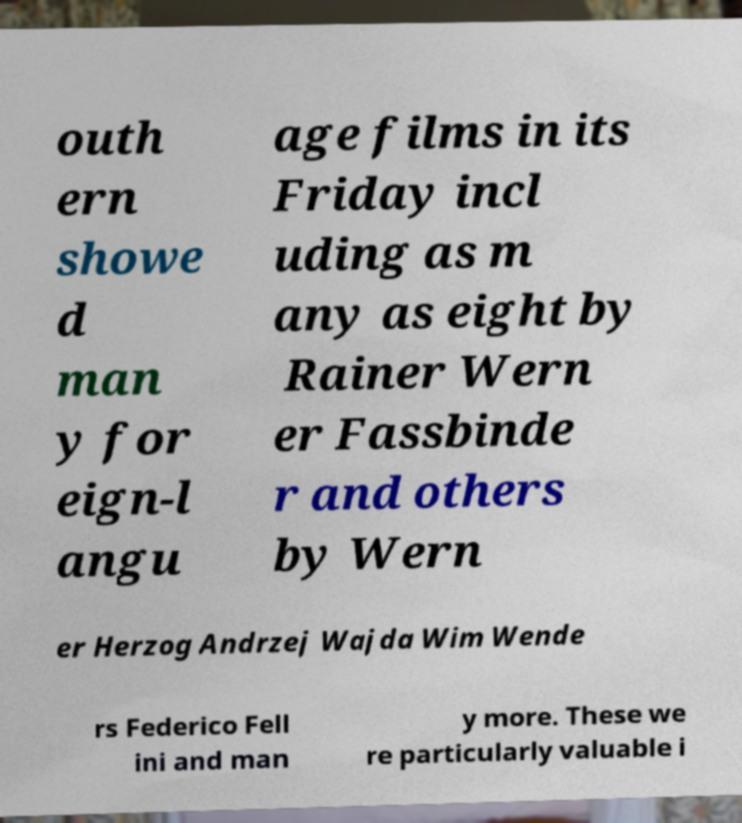Could you extract and type out the text from this image? outh ern showe d man y for eign-l angu age films in its Friday incl uding as m any as eight by Rainer Wern er Fassbinde r and others by Wern er Herzog Andrzej Wajda Wim Wende rs Federico Fell ini and man y more. These we re particularly valuable i 